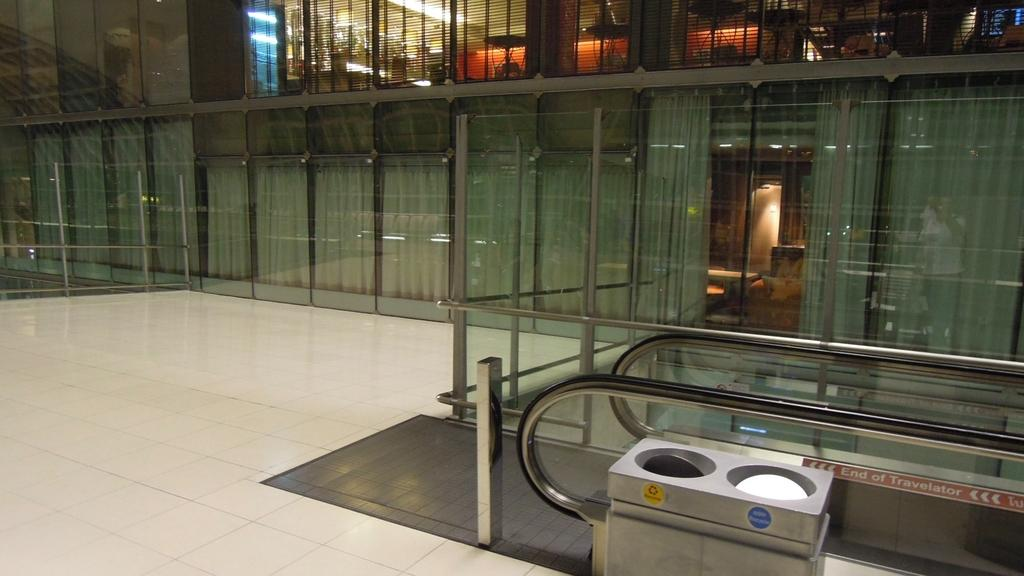<image>
Present a compact description of the photo's key features. A label on an escalator says End of Traveler. 